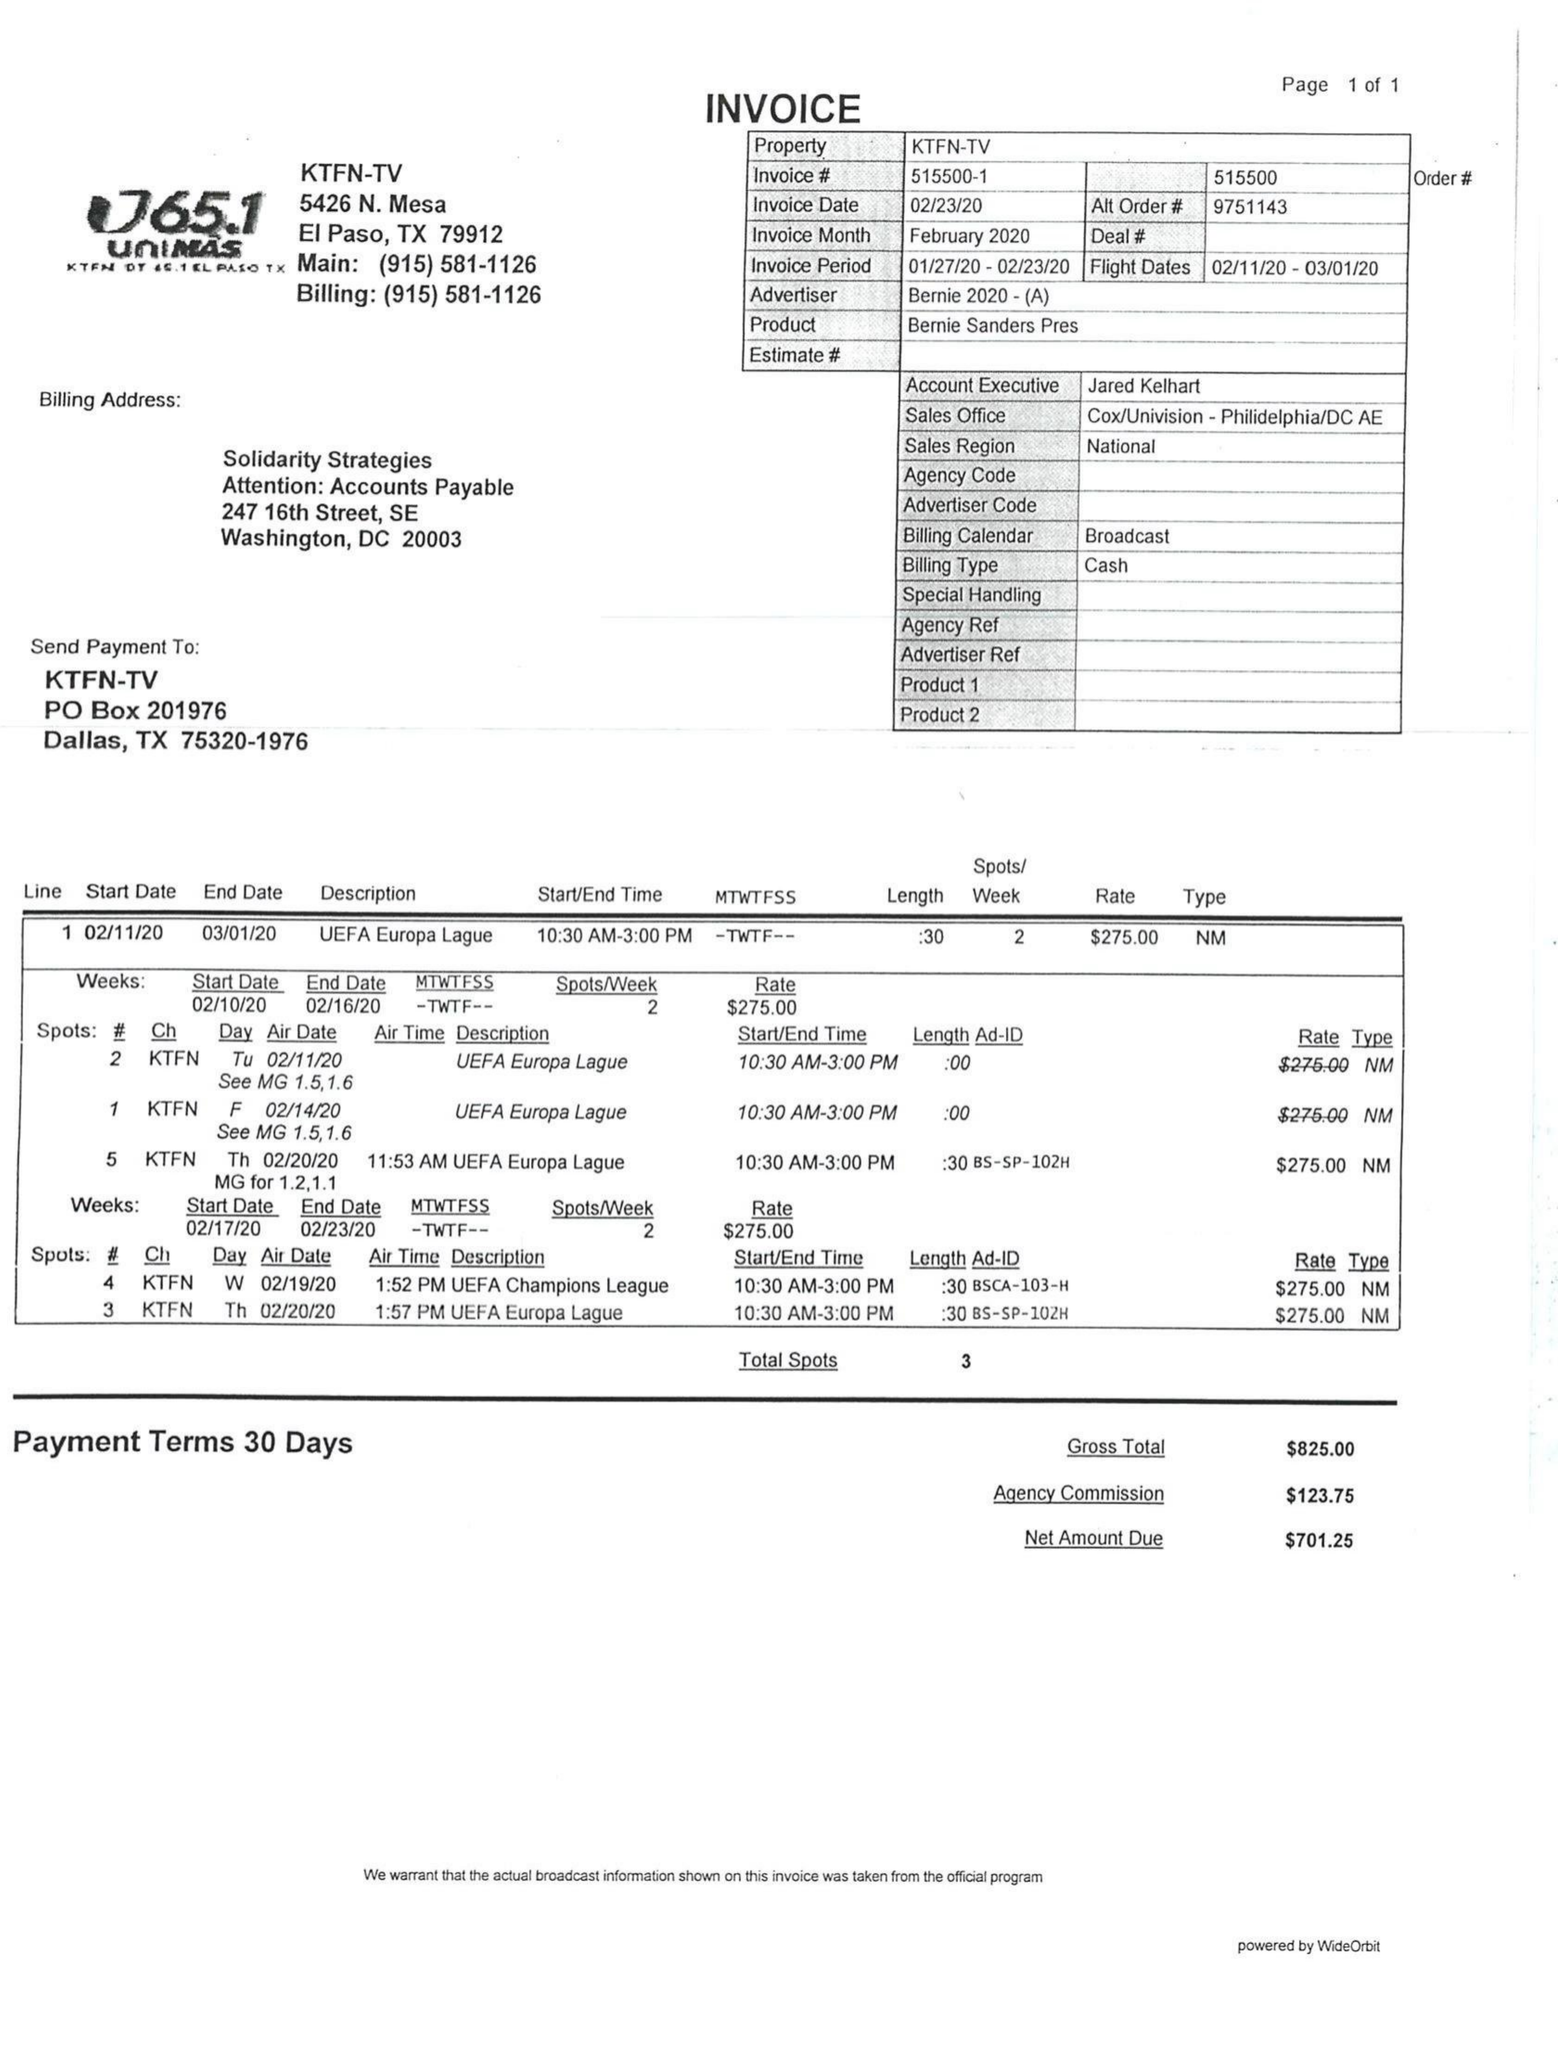What is the value for the advertiser?
Answer the question using a single word or phrase. BERNIE 2020 - (A) 